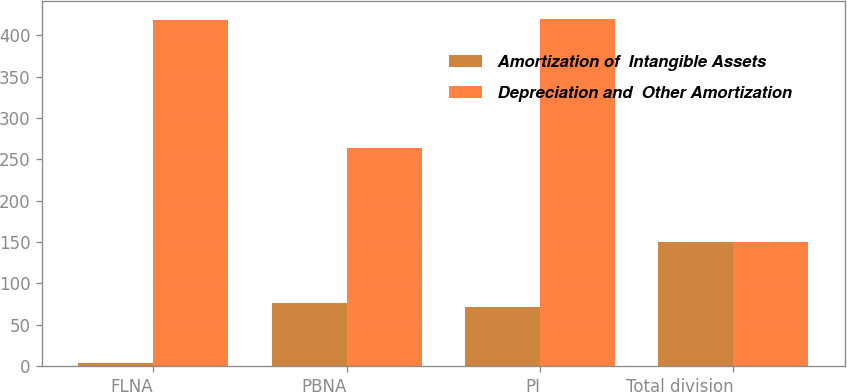Convert chart. <chart><loc_0><loc_0><loc_500><loc_500><stacked_bar_chart><ecel><fcel>FLNA<fcel>PBNA<fcel>PI<fcel>Total division<nl><fcel>Amortization of  Intangible Assets<fcel>3<fcel>76<fcel>71<fcel>150<nl><fcel>Depreciation and  Other Amortization<fcel>419<fcel>264<fcel>420<fcel>150<nl></chart> 